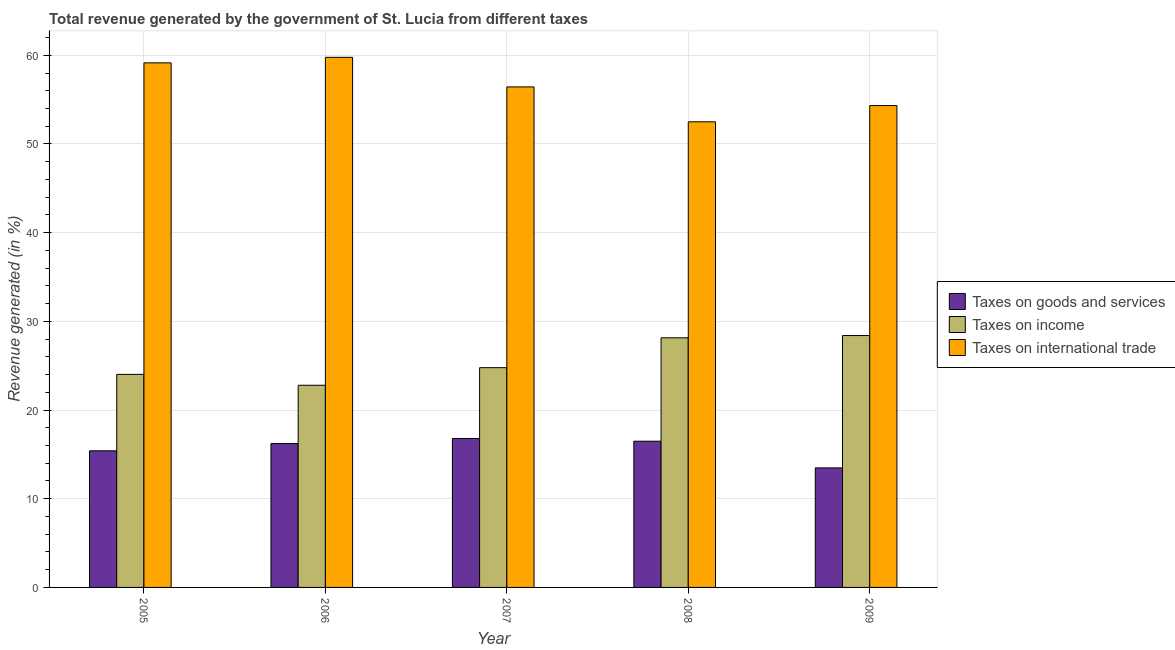How many groups of bars are there?
Ensure brevity in your answer.  5. Are the number of bars per tick equal to the number of legend labels?
Make the answer very short. Yes. How many bars are there on the 5th tick from the right?
Your answer should be compact. 3. In how many cases, is the number of bars for a given year not equal to the number of legend labels?
Your answer should be compact. 0. What is the percentage of revenue generated by tax on international trade in 2006?
Offer a terse response. 59.77. Across all years, what is the maximum percentage of revenue generated by tax on international trade?
Your response must be concise. 59.77. Across all years, what is the minimum percentage of revenue generated by tax on international trade?
Your answer should be compact. 52.5. In which year was the percentage of revenue generated by taxes on goods and services minimum?
Make the answer very short. 2009. What is the total percentage of revenue generated by tax on international trade in the graph?
Give a very brief answer. 282.18. What is the difference between the percentage of revenue generated by taxes on goods and services in 2007 and that in 2009?
Your answer should be compact. 3.32. What is the difference between the percentage of revenue generated by tax on international trade in 2007 and the percentage of revenue generated by taxes on income in 2006?
Your answer should be very brief. -3.34. What is the average percentage of revenue generated by taxes on income per year?
Keep it short and to the point. 25.63. What is the ratio of the percentage of revenue generated by taxes on goods and services in 2006 to that in 2008?
Offer a terse response. 0.98. Is the percentage of revenue generated by tax on international trade in 2006 less than that in 2008?
Your answer should be very brief. No. Is the difference between the percentage of revenue generated by taxes on income in 2005 and 2006 greater than the difference between the percentage of revenue generated by taxes on goods and services in 2005 and 2006?
Offer a very short reply. No. What is the difference between the highest and the second highest percentage of revenue generated by tax on international trade?
Your response must be concise. 0.62. What is the difference between the highest and the lowest percentage of revenue generated by tax on international trade?
Offer a terse response. 7.27. Is the sum of the percentage of revenue generated by taxes on goods and services in 2005 and 2009 greater than the maximum percentage of revenue generated by taxes on income across all years?
Your response must be concise. Yes. What does the 1st bar from the left in 2006 represents?
Offer a terse response. Taxes on goods and services. What does the 1st bar from the right in 2008 represents?
Your response must be concise. Taxes on international trade. Are the values on the major ticks of Y-axis written in scientific E-notation?
Your response must be concise. No. Where does the legend appear in the graph?
Provide a short and direct response. Center right. What is the title of the graph?
Make the answer very short. Total revenue generated by the government of St. Lucia from different taxes. Does "Female employers" appear as one of the legend labels in the graph?
Provide a succinct answer. No. What is the label or title of the X-axis?
Offer a very short reply. Year. What is the label or title of the Y-axis?
Offer a very short reply. Revenue generated (in %). What is the Revenue generated (in %) of Taxes on goods and services in 2005?
Make the answer very short. 15.4. What is the Revenue generated (in %) in Taxes on income in 2005?
Your answer should be very brief. 24.02. What is the Revenue generated (in %) of Taxes on international trade in 2005?
Provide a short and direct response. 59.15. What is the Revenue generated (in %) of Taxes on goods and services in 2006?
Your answer should be compact. 16.22. What is the Revenue generated (in %) of Taxes on income in 2006?
Ensure brevity in your answer.  22.8. What is the Revenue generated (in %) in Taxes on international trade in 2006?
Offer a very short reply. 59.77. What is the Revenue generated (in %) of Taxes on goods and services in 2007?
Provide a succinct answer. 16.8. What is the Revenue generated (in %) of Taxes on income in 2007?
Offer a terse response. 24.78. What is the Revenue generated (in %) of Taxes on international trade in 2007?
Make the answer very short. 56.43. What is the Revenue generated (in %) in Taxes on goods and services in 2008?
Give a very brief answer. 16.49. What is the Revenue generated (in %) of Taxes on income in 2008?
Ensure brevity in your answer.  28.15. What is the Revenue generated (in %) of Taxes on international trade in 2008?
Your response must be concise. 52.5. What is the Revenue generated (in %) of Taxes on goods and services in 2009?
Provide a succinct answer. 13.48. What is the Revenue generated (in %) in Taxes on income in 2009?
Give a very brief answer. 28.4. What is the Revenue generated (in %) of Taxes on international trade in 2009?
Your response must be concise. 54.33. Across all years, what is the maximum Revenue generated (in %) of Taxes on goods and services?
Your response must be concise. 16.8. Across all years, what is the maximum Revenue generated (in %) of Taxes on income?
Keep it short and to the point. 28.4. Across all years, what is the maximum Revenue generated (in %) in Taxes on international trade?
Provide a succinct answer. 59.77. Across all years, what is the minimum Revenue generated (in %) in Taxes on goods and services?
Your answer should be compact. 13.48. Across all years, what is the minimum Revenue generated (in %) in Taxes on income?
Your response must be concise. 22.8. Across all years, what is the minimum Revenue generated (in %) of Taxes on international trade?
Your response must be concise. 52.5. What is the total Revenue generated (in %) of Taxes on goods and services in the graph?
Offer a terse response. 78.38. What is the total Revenue generated (in %) in Taxes on income in the graph?
Make the answer very short. 128.14. What is the total Revenue generated (in %) in Taxes on international trade in the graph?
Offer a terse response. 282.18. What is the difference between the Revenue generated (in %) in Taxes on goods and services in 2005 and that in 2006?
Keep it short and to the point. -0.82. What is the difference between the Revenue generated (in %) in Taxes on income in 2005 and that in 2006?
Provide a short and direct response. 1.23. What is the difference between the Revenue generated (in %) in Taxes on international trade in 2005 and that in 2006?
Provide a short and direct response. -0.62. What is the difference between the Revenue generated (in %) in Taxes on goods and services in 2005 and that in 2007?
Offer a very short reply. -1.39. What is the difference between the Revenue generated (in %) of Taxes on income in 2005 and that in 2007?
Ensure brevity in your answer.  -0.76. What is the difference between the Revenue generated (in %) of Taxes on international trade in 2005 and that in 2007?
Keep it short and to the point. 2.71. What is the difference between the Revenue generated (in %) of Taxes on goods and services in 2005 and that in 2008?
Ensure brevity in your answer.  -1.08. What is the difference between the Revenue generated (in %) in Taxes on income in 2005 and that in 2008?
Offer a terse response. -4.12. What is the difference between the Revenue generated (in %) in Taxes on international trade in 2005 and that in 2008?
Ensure brevity in your answer.  6.65. What is the difference between the Revenue generated (in %) in Taxes on goods and services in 2005 and that in 2009?
Make the answer very short. 1.92. What is the difference between the Revenue generated (in %) of Taxes on income in 2005 and that in 2009?
Provide a short and direct response. -4.38. What is the difference between the Revenue generated (in %) in Taxes on international trade in 2005 and that in 2009?
Provide a succinct answer. 4.82. What is the difference between the Revenue generated (in %) in Taxes on goods and services in 2006 and that in 2007?
Keep it short and to the point. -0.57. What is the difference between the Revenue generated (in %) in Taxes on income in 2006 and that in 2007?
Give a very brief answer. -1.98. What is the difference between the Revenue generated (in %) in Taxes on international trade in 2006 and that in 2007?
Make the answer very short. 3.34. What is the difference between the Revenue generated (in %) of Taxes on goods and services in 2006 and that in 2008?
Offer a very short reply. -0.26. What is the difference between the Revenue generated (in %) of Taxes on income in 2006 and that in 2008?
Ensure brevity in your answer.  -5.35. What is the difference between the Revenue generated (in %) of Taxes on international trade in 2006 and that in 2008?
Offer a very short reply. 7.27. What is the difference between the Revenue generated (in %) in Taxes on goods and services in 2006 and that in 2009?
Keep it short and to the point. 2.74. What is the difference between the Revenue generated (in %) in Taxes on income in 2006 and that in 2009?
Provide a short and direct response. -5.61. What is the difference between the Revenue generated (in %) in Taxes on international trade in 2006 and that in 2009?
Your answer should be very brief. 5.44. What is the difference between the Revenue generated (in %) in Taxes on goods and services in 2007 and that in 2008?
Provide a short and direct response. 0.31. What is the difference between the Revenue generated (in %) in Taxes on income in 2007 and that in 2008?
Your response must be concise. -3.37. What is the difference between the Revenue generated (in %) in Taxes on international trade in 2007 and that in 2008?
Offer a very short reply. 3.93. What is the difference between the Revenue generated (in %) in Taxes on goods and services in 2007 and that in 2009?
Provide a succinct answer. 3.32. What is the difference between the Revenue generated (in %) of Taxes on income in 2007 and that in 2009?
Your answer should be compact. -3.62. What is the difference between the Revenue generated (in %) in Taxes on international trade in 2007 and that in 2009?
Keep it short and to the point. 2.1. What is the difference between the Revenue generated (in %) of Taxes on goods and services in 2008 and that in 2009?
Offer a terse response. 3.01. What is the difference between the Revenue generated (in %) in Taxes on income in 2008 and that in 2009?
Provide a succinct answer. -0.26. What is the difference between the Revenue generated (in %) of Taxes on international trade in 2008 and that in 2009?
Ensure brevity in your answer.  -1.83. What is the difference between the Revenue generated (in %) in Taxes on goods and services in 2005 and the Revenue generated (in %) in Taxes on income in 2006?
Provide a short and direct response. -7.39. What is the difference between the Revenue generated (in %) in Taxes on goods and services in 2005 and the Revenue generated (in %) in Taxes on international trade in 2006?
Ensure brevity in your answer.  -44.37. What is the difference between the Revenue generated (in %) in Taxes on income in 2005 and the Revenue generated (in %) in Taxes on international trade in 2006?
Make the answer very short. -35.75. What is the difference between the Revenue generated (in %) in Taxes on goods and services in 2005 and the Revenue generated (in %) in Taxes on income in 2007?
Offer a very short reply. -9.38. What is the difference between the Revenue generated (in %) of Taxes on goods and services in 2005 and the Revenue generated (in %) of Taxes on international trade in 2007?
Your response must be concise. -41.03. What is the difference between the Revenue generated (in %) in Taxes on income in 2005 and the Revenue generated (in %) in Taxes on international trade in 2007?
Provide a succinct answer. -32.41. What is the difference between the Revenue generated (in %) of Taxes on goods and services in 2005 and the Revenue generated (in %) of Taxes on income in 2008?
Offer a very short reply. -12.74. What is the difference between the Revenue generated (in %) in Taxes on goods and services in 2005 and the Revenue generated (in %) in Taxes on international trade in 2008?
Offer a very short reply. -37.1. What is the difference between the Revenue generated (in %) of Taxes on income in 2005 and the Revenue generated (in %) of Taxes on international trade in 2008?
Offer a terse response. -28.48. What is the difference between the Revenue generated (in %) of Taxes on goods and services in 2005 and the Revenue generated (in %) of Taxes on income in 2009?
Give a very brief answer. -13. What is the difference between the Revenue generated (in %) of Taxes on goods and services in 2005 and the Revenue generated (in %) of Taxes on international trade in 2009?
Provide a succinct answer. -38.93. What is the difference between the Revenue generated (in %) in Taxes on income in 2005 and the Revenue generated (in %) in Taxes on international trade in 2009?
Ensure brevity in your answer.  -30.31. What is the difference between the Revenue generated (in %) in Taxes on goods and services in 2006 and the Revenue generated (in %) in Taxes on income in 2007?
Offer a terse response. -8.56. What is the difference between the Revenue generated (in %) in Taxes on goods and services in 2006 and the Revenue generated (in %) in Taxes on international trade in 2007?
Provide a succinct answer. -40.21. What is the difference between the Revenue generated (in %) of Taxes on income in 2006 and the Revenue generated (in %) of Taxes on international trade in 2007?
Your answer should be very brief. -33.64. What is the difference between the Revenue generated (in %) in Taxes on goods and services in 2006 and the Revenue generated (in %) in Taxes on income in 2008?
Offer a very short reply. -11.92. What is the difference between the Revenue generated (in %) in Taxes on goods and services in 2006 and the Revenue generated (in %) in Taxes on international trade in 2008?
Offer a terse response. -36.28. What is the difference between the Revenue generated (in %) in Taxes on income in 2006 and the Revenue generated (in %) in Taxes on international trade in 2008?
Give a very brief answer. -29.7. What is the difference between the Revenue generated (in %) in Taxes on goods and services in 2006 and the Revenue generated (in %) in Taxes on income in 2009?
Ensure brevity in your answer.  -12.18. What is the difference between the Revenue generated (in %) in Taxes on goods and services in 2006 and the Revenue generated (in %) in Taxes on international trade in 2009?
Make the answer very short. -38.11. What is the difference between the Revenue generated (in %) in Taxes on income in 2006 and the Revenue generated (in %) in Taxes on international trade in 2009?
Your response must be concise. -31.53. What is the difference between the Revenue generated (in %) of Taxes on goods and services in 2007 and the Revenue generated (in %) of Taxes on income in 2008?
Keep it short and to the point. -11.35. What is the difference between the Revenue generated (in %) of Taxes on goods and services in 2007 and the Revenue generated (in %) of Taxes on international trade in 2008?
Offer a very short reply. -35.7. What is the difference between the Revenue generated (in %) in Taxes on income in 2007 and the Revenue generated (in %) in Taxes on international trade in 2008?
Your answer should be compact. -27.72. What is the difference between the Revenue generated (in %) in Taxes on goods and services in 2007 and the Revenue generated (in %) in Taxes on income in 2009?
Provide a succinct answer. -11.61. What is the difference between the Revenue generated (in %) in Taxes on goods and services in 2007 and the Revenue generated (in %) in Taxes on international trade in 2009?
Provide a succinct answer. -37.53. What is the difference between the Revenue generated (in %) in Taxes on income in 2007 and the Revenue generated (in %) in Taxes on international trade in 2009?
Provide a short and direct response. -29.55. What is the difference between the Revenue generated (in %) of Taxes on goods and services in 2008 and the Revenue generated (in %) of Taxes on income in 2009?
Ensure brevity in your answer.  -11.92. What is the difference between the Revenue generated (in %) of Taxes on goods and services in 2008 and the Revenue generated (in %) of Taxes on international trade in 2009?
Keep it short and to the point. -37.84. What is the difference between the Revenue generated (in %) in Taxes on income in 2008 and the Revenue generated (in %) in Taxes on international trade in 2009?
Make the answer very short. -26.18. What is the average Revenue generated (in %) of Taxes on goods and services per year?
Provide a succinct answer. 15.68. What is the average Revenue generated (in %) in Taxes on income per year?
Offer a terse response. 25.63. What is the average Revenue generated (in %) of Taxes on international trade per year?
Give a very brief answer. 56.44. In the year 2005, what is the difference between the Revenue generated (in %) in Taxes on goods and services and Revenue generated (in %) in Taxes on income?
Your answer should be compact. -8.62. In the year 2005, what is the difference between the Revenue generated (in %) in Taxes on goods and services and Revenue generated (in %) in Taxes on international trade?
Your answer should be compact. -43.74. In the year 2005, what is the difference between the Revenue generated (in %) in Taxes on income and Revenue generated (in %) in Taxes on international trade?
Ensure brevity in your answer.  -35.12. In the year 2006, what is the difference between the Revenue generated (in %) of Taxes on goods and services and Revenue generated (in %) of Taxes on income?
Ensure brevity in your answer.  -6.57. In the year 2006, what is the difference between the Revenue generated (in %) of Taxes on goods and services and Revenue generated (in %) of Taxes on international trade?
Your answer should be compact. -43.55. In the year 2006, what is the difference between the Revenue generated (in %) in Taxes on income and Revenue generated (in %) in Taxes on international trade?
Provide a short and direct response. -36.97. In the year 2007, what is the difference between the Revenue generated (in %) in Taxes on goods and services and Revenue generated (in %) in Taxes on income?
Your answer should be very brief. -7.98. In the year 2007, what is the difference between the Revenue generated (in %) of Taxes on goods and services and Revenue generated (in %) of Taxes on international trade?
Ensure brevity in your answer.  -39.64. In the year 2007, what is the difference between the Revenue generated (in %) in Taxes on income and Revenue generated (in %) in Taxes on international trade?
Offer a terse response. -31.65. In the year 2008, what is the difference between the Revenue generated (in %) in Taxes on goods and services and Revenue generated (in %) in Taxes on income?
Provide a short and direct response. -11.66. In the year 2008, what is the difference between the Revenue generated (in %) in Taxes on goods and services and Revenue generated (in %) in Taxes on international trade?
Offer a very short reply. -36.01. In the year 2008, what is the difference between the Revenue generated (in %) of Taxes on income and Revenue generated (in %) of Taxes on international trade?
Your response must be concise. -24.35. In the year 2009, what is the difference between the Revenue generated (in %) of Taxes on goods and services and Revenue generated (in %) of Taxes on income?
Keep it short and to the point. -14.92. In the year 2009, what is the difference between the Revenue generated (in %) in Taxes on goods and services and Revenue generated (in %) in Taxes on international trade?
Ensure brevity in your answer.  -40.85. In the year 2009, what is the difference between the Revenue generated (in %) in Taxes on income and Revenue generated (in %) in Taxes on international trade?
Make the answer very short. -25.93. What is the ratio of the Revenue generated (in %) in Taxes on goods and services in 2005 to that in 2006?
Provide a succinct answer. 0.95. What is the ratio of the Revenue generated (in %) of Taxes on income in 2005 to that in 2006?
Make the answer very short. 1.05. What is the ratio of the Revenue generated (in %) in Taxes on goods and services in 2005 to that in 2007?
Provide a succinct answer. 0.92. What is the ratio of the Revenue generated (in %) of Taxes on income in 2005 to that in 2007?
Keep it short and to the point. 0.97. What is the ratio of the Revenue generated (in %) of Taxes on international trade in 2005 to that in 2007?
Provide a succinct answer. 1.05. What is the ratio of the Revenue generated (in %) of Taxes on goods and services in 2005 to that in 2008?
Offer a terse response. 0.93. What is the ratio of the Revenue generated (in %) in Taxes on income in 2005 to that in 2008?
Offer a terse response. 0.85. What is the ratio of the Revenue generated (in %) in Taxes on international trade in 2005 to that in 2008?
Provide a succinct answer. 1.13. What is the ratio of the Revenue generated (in %) in Taxes on goods and services in 2005 to that in 2009?
Make the answer very short. 1.14. What is the ratio of the Revenue generated (in %) of Taxes on income in 2005 to that in 2009?
Offer a terse response. 0.85. What is the ratio of the Revenue generated (in %) in Taxes on international trade in 2005 to that in 2009?
Make the answer very short. 1.09. What is the ratio of the Revenue generated (in %) in Taxes on goods and services in 2006 to that in 2007?
Your answer should be very brief. 0.97. What is the ratio of the Revenue generated (in %) in Taxes on international trade in 2006 to that in 2007?
Make the answer very short. 1.06. What is the ratio of the Revenue generated (in %) of Taxes on goods and services in 2006 to that in 2008?
Give a very brief answer. 0.98. What is the ratio of the Revenue generated (in %) of Taxes on income in 2006 to that in 2008?
Make the answer very short. 0.81. What is the ratio of the Revenue generated (in %) in Taxes on international trade in 2006 to that in 2008?
Your answer should be very brief. 1.14. What is the ratio of the Revenue generated (in %) of Taxes on goods and services in 2006 to that in 2009?
Keep it short and to the point. 1.2. What is the ratio of the Revenue generated (in %) of Taxes on income in 2006 to that in 2009?
Give a very brief answer. 0.8. What is the ratio of the Revenue generated (in %) of Taxes on international trade in 2006 to that in 2009?
Give a very brief answer. 1.1. What is the ratio of the Revenue generated (in %) in Taxes on goods and services in 2007 to that in 2008?
Offer a very short reply. 1.02. What is the ratio of the Revenue generated (in %) in Taxes on income in 2007 to that in 2008?
Provide a short and direct response. 0.88. What is the ratio of the Revenue generated (in %) in Taxes on international trade in 2007 to that in 2008?
Your response must be concise. 1.07. What is the ratio of the Revenue generated (in %) of Taxes on goods and services in 2007 to that in 2009?
Offer a terse response. 1.25. What is the ratio of the Revenue generated (in %) of Taxes on income in 2007 to that in 2009?
Provide a succinct answer. 0.87. What is the ratio of the Revenue generated (in %) in Taxes on international trade in 2007 to that in 2009?
Ensure brevity in your answer.  1.04. What is the ratio of the Revenue generated (in %) in Taxes on goods and services in 2008 to that in 2009?
Provide a short and direct response. 1.22. What is the ratio of the Revenue generated (in %) in Taxes on income in 2008 to that in 2009?
Your answer should be very brief. 0.99. What is the ratio of the Revenue generated (in %) of Taxes on international trade in 2008 to that in 2009?
Offer a terse response. 0.97. What is the difference between the highest and the second highest Revenue generated (in %) in Taxes on goods and services?
Make the answer very short. 0.31. What is the difference between the highest and the second highest Revenue generated (in %) of Taxes on income?
Make the answer very short. 0.26. What is the difference between the highest and the second highest Revenue generated (in %) in Taxes on international trade?
Ensure brevity in your answer.  0.62. What is the difference between the highest and the lowest Revenue generated (in %) in Taxes on goods and services?
Give a very brief answer. 3.32. What is the difference between the highest and the lowest Revenue generated (in %) in Taxes on income?
Keep it short and to the point. 5.61. What is the difference between the highest and the lowest Revenue generated (in %) in Taxes on international trade?
Your response must be concise. 7.27. 